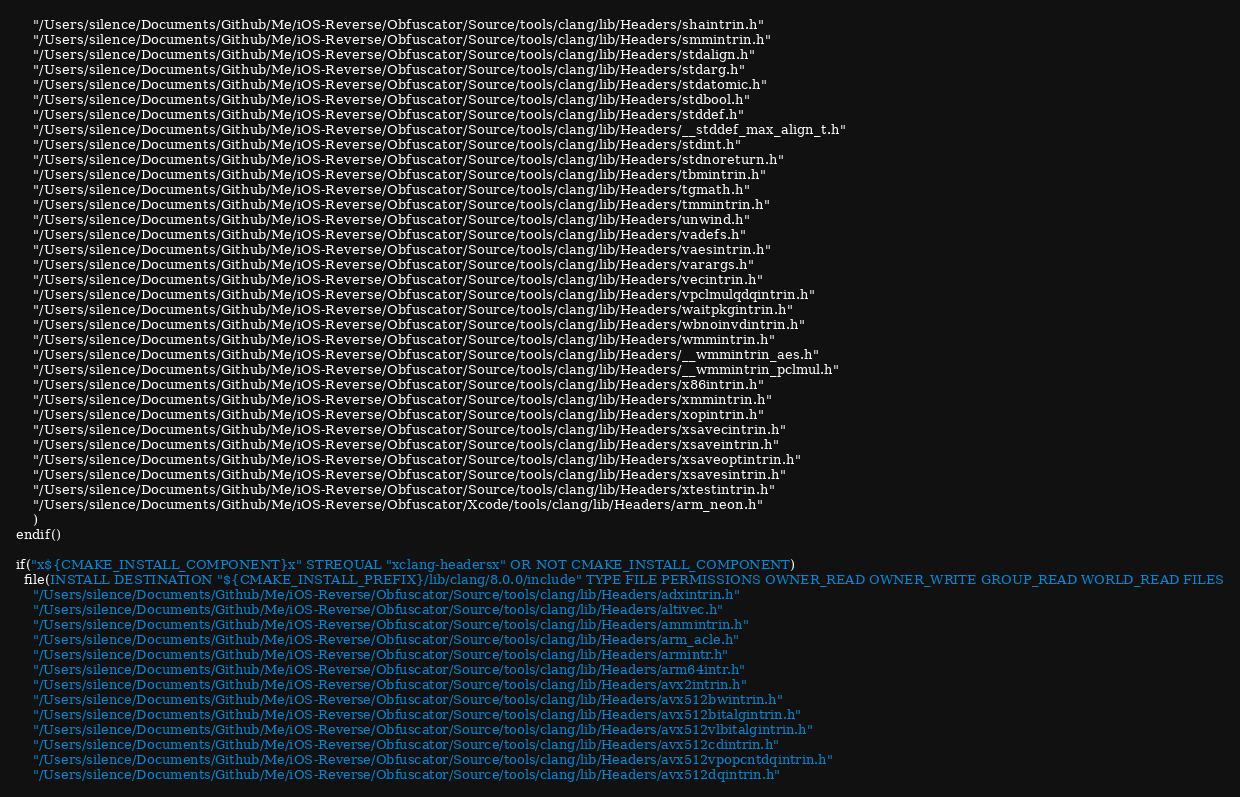<code> <loc_0><loc_0><loc_500><loc_500><_CMake_>    "/Users/silence/Documents/Github/Me/iOS-Reverse/Obfuscator/Source/tools/clang/lib/Headers/shaintrin.h"
    "/Users/silence/Documents/Github/Me/iOS-Reverse/Obfuscator/Source/tools/clang/lib/Headers/smmintrin.h"
    "/Users/silence/Documents/Github/Me/iOS-Reverse/Obfuscator/Source/tools/clang/lib/Headers/stdalign.h"
    "/Users/silence/Documents/Github/Me/iOS-Reverse/Obfuscator/Source/tools/clang/lib/Headers/stdarg.h"
    "/Users/silence/Documents/Github/Me/iOS-Reverse/Obfuscator/Source/tools/clang/lib/Headers/stdatomic.h"
    "/Users/silence/Documents/Github/Me/iOS-Reverse/Obfuscator/Source/tools/clang/lib/Headers/stdbool.h"
    "/Users/silence/Documents/Github/Me/iOS-Reverse/Obfuscator/Source/tools/clang/lib/Headers/stddef.h"
    "/Users/silence/Documents/Github/Me/iOS-Reverse/Obfuscator/Source/tools/clang/lib/Headers/__stddef_max_align_t.h"
    "/Users/silence/Documents/Github/Me/iOS-Reverse/Obfuscator/Source/tools/clang/lib/Headers/stdint.h"
    "/Users/silence/Documents/Github/Me/iOS-Reverse/Obfuscator/Source/tools/clang/lib/Headers/stdnoreturn.h"
    "/Users/silence/Documents/Github/Me/iOS-Reverse/Obfuscator/Source/tools/clang/lib/Headers/tbmintrin.h"
    "/Users/silence/Documents/Github/Me/iOS-Reverse/Obfuscator/Source/tools/clang/lib/Headers/tgmath.h"
    "/Users/silence/Documents/Github/Me/iOS-Reverse/Obfuscator/Source/tools/clang/lib/Headers/tmmintrin.h"
    "/Users/silence/Documents/Github/Me/iOS-Reverse/Obfuscator/Source/tools/clang/lib/Headers/unwind.h"
    "/Users/silence/Documents/Github/Me/iOS-Reverse/Obfuscator/Source/tools/clang/lib/Headers/vadefs.h"
    "/Users/silence/Documents/Github/Me/iOS-Reverse/Obfuscator/Source/tools/clang/lib/Headers/vaesintrin.h"
    "/Users/silence/Documents/Github/Me/iOS-Reverse/Obfuscator/Source/tools/clang/lib/Headers/varargs.h"
    "/Users/silence/Documents/Github/Me/iOS-Reverse/Obfuscator/Source/tools/clang/lib/Headers/vecintrin.h"
    "/Users/silence/Documents/Github/Me/iOS-Reverse/Obfuscator/Source/tools/clang/lib/Headers/vpclmulqdqintrin.h"
    "/Users/silence/Documents/Github/Me/iOS-Reverse/Obfuscator/Source/tools/clang/lib/Headers/waitpkgintrin.h"
    "/Users/silence/Documents/Github/Me/iOS-Reverse/Obfuscator/Source/tools/clang/lib/Headers/wbnoinvdintrin.h"
    "/Users/silence/Documents/Github/Me/iOS-Reverse/Obfuscator/Source/tools/clang/lib/Headers/wmmintrin.h"
    "/Users/silence/Documents/Github/Me/iOS-Reverse/Obfuscator/Source/tools/clang/lib/Headers/__wmmintrin_aes.h"
    "/Users/silence/Documents/Github/Me/iOS-Reverse/Obfuscator/Source/tools/clang/lib/Headers/__wmmintrin_pclmul.h"
    "/Users/silence/Documents/Github/Me/iOS-Reverse/Obfuscator/Source/tools/clang/lib/Headers/x86intrin.h"
    "/Users/silence/Documents/Github/Me/iOS-Reverse/Obfuscator/Source/tools/clang/lib/Headers/xmmintrin.h"
    "/Users/silence/Documents/Github/Me/iOS-Reverse/Obfuscator/Source/tools/clang/lib/Headers/xopintrin.h"
    "/Users/silence/Documents/Github/Me/iOS-Reverse/Obfuscator/Source/tools/clang/lib/Headers/xsavecintrin.h"
    "/Users/silence/Documents/Github/Me/iOS-Reverse/Obfuscator/Source/tools/clang/lib/Headers/xsaveintrin.h"
    "/Users/silence/Documents/Github/Me/iOS-Reverse/Obfuscator/Source/tools/clang/lib/Headers/xsaveoptintrin.h"
    "/Users/silence/Documents/Github/Me/iOS-Reverse/Obfuscator/Source/tools/clang/lib/Headers/xsavesintrin.h"
    "/Users/silence/Documents/Github/Me/iOS-Reverse/Obfuscator/Source/tools/clang/lib/Headers/xtestintrin.h"
    "/Users/silence/Documents/Github/Me/iOS-Reverse/Obfuscator/Xcode/tools/clang/lib/Headers/arm_neon.h"
    )
endif()

if("x${CMAKE_INSTALL_COMPONENT}x" STREQUAL "xclang-headersx" OR NOT CMAKE_INSTALL_COMPONENT)
  file(INSTALL DESTINATION "${CMAKE_INSTALL_PREFIX}/lib/clang/8.0.0/include" TYPE FILE PERMISSIONS OWNER_READ OWNER_WRITE GROUP_READ WORLD_READ FILES
    "/Users/silence/Documents/Github/Me/iOS-Reverse/Obfuscator/Source/tools/clang/lib/Headers/adxintrin.h"
    "/Users/silence/Documents/Github/Me/iOS-Reverse/Obfuscator/Source/tools/clang/lib/Headers/altivec.h"
    "/Users/silence/Documents/Github/Me/iOS-Reverse/Obfuscator/Source/tools/clang/lib/Headers/ammintrin.h"
    "/Users/silence/Documents/Github/Me/iOS-Reverse/Obfuscator/Source/tools/clang/lib/Headers/arm_acle.h"
    "/Users/silence/Documents/Github/Me/iOS-Reverse/Obfuscator/Source/tools/clang/lib/Headers/armintr.h"
    "/Users/silence/Documents/Github/Me/iOS-Reverse/Obfuscator/Source/tools/clang/lib/Headers/arm64intr.h"
    "/Users/silence/Documents/Github/Me/iOS-Reverse/Obfuscator/Source/tools/clang/lib/Headers/avx2intrin.h"
    "/Users/silence/Documents/Github/Me/iOS-Reverse/Obfuscator/Source/tools/clang/lib/Headers/avx512bwintrin.h"
    "/Users/silence/Documents/Github/Me/iOS-Reverse/Obfuscator/Source/tools/clang/lib/Headers/avx512bitalgintrin.h"
    "/Users/silence/Documents/Github/Me/iOS-Reverse/Obfuscator/Source/tools/clang/lib/Headers/avx512vlbitalgintrin.h"
    "/Users/silence/Documents/Github/Me/iOS-Reverse/Obfuscator/Source/tools/clang/lib/Headers/avx512cdintrin.h"
    "/Users/silence/Documents/Github/Me/iOS-Reverse/Obfuscator/Source/tools/clang/lib/Headers/avx512vpopcntdqintrin.h"
    "/Users/silence/Documents/Github/Me/iOS-Reverse/Obfuscator/Source/tools/clang/lib/Headers/avx512dqintrin.h"</code> 